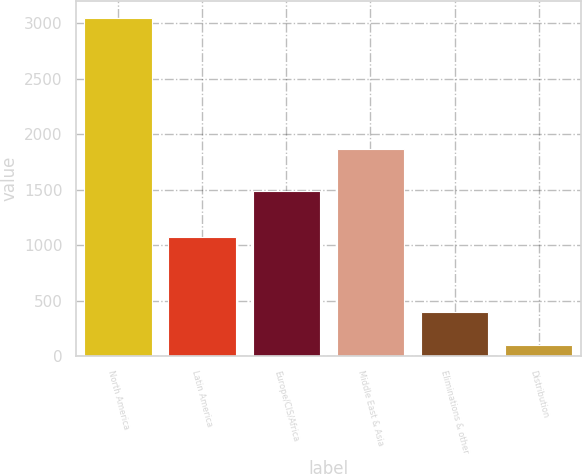<chart> <loc_0><loc_0><loc_500><loc_500><bar_chart><fcel>North America<fcel>Latin America<fcel>Europe/CIS/Africa<fcel>Middle East & Asia<fcel>Eliminations & other<fcel>Distribution<nl><fcel>3051<fcel>1072<fcel>1489<fcel>1868<fcel>397.8<fcel>103<nl></chart> 